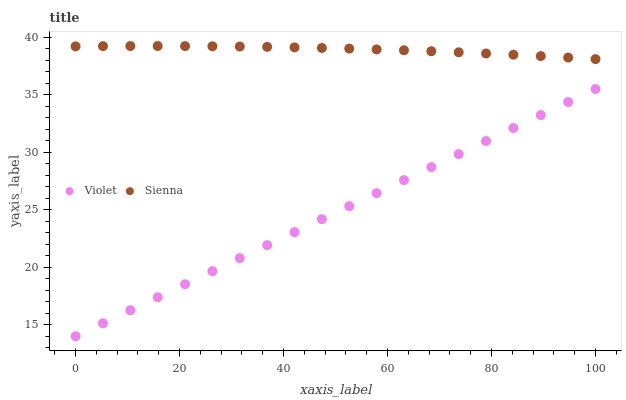Does Violet have the minimum area under the curve?
Answer yes or no. Yes. Does Sienna have the maximum area under the curve?
Answer yes or no. Yes. Does Violet have the maximum area under the curve?
Answer yes or no. No. Is Violet the smoothest?
Answer yes or no. Yes. Is Sienna the roughest?
Answer yes or no. Yes. Is Violet the roughest?
Answer yes or no. No. Does Violet have the lowest value?
Answer yes or no. Yes. Does Sienna have the highest value?
Answer yes or no. Yes. Does Violet have the highest value?
Answer yes or no. No. Is Violet less than Sienna?
Answer yes or no. Yes. Is Sienna greater than Violet?
Answer yes or no. Yes. Does Violet intersect Sienna?
Answer yes or no. No. 